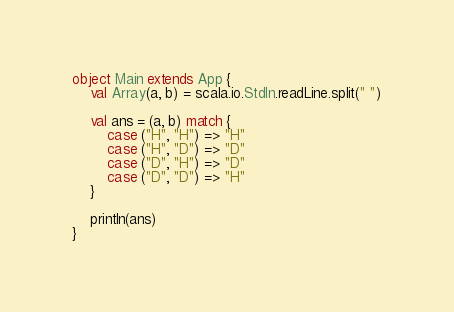<code> <loc_0><loc_0><loc_500><loc_500><_Scala_>object Main extends App {
	val Array(a, b) = scala.io.StdIn.readLine.split(" ")

	val ans = (a, b) match {
		case ("H", "H") => "H"
		case ("H", "D") => "D"
		case ("D", "H") => "D"
		case ("D", "D") => "H"
	}

	println(ans)
}
</code> 